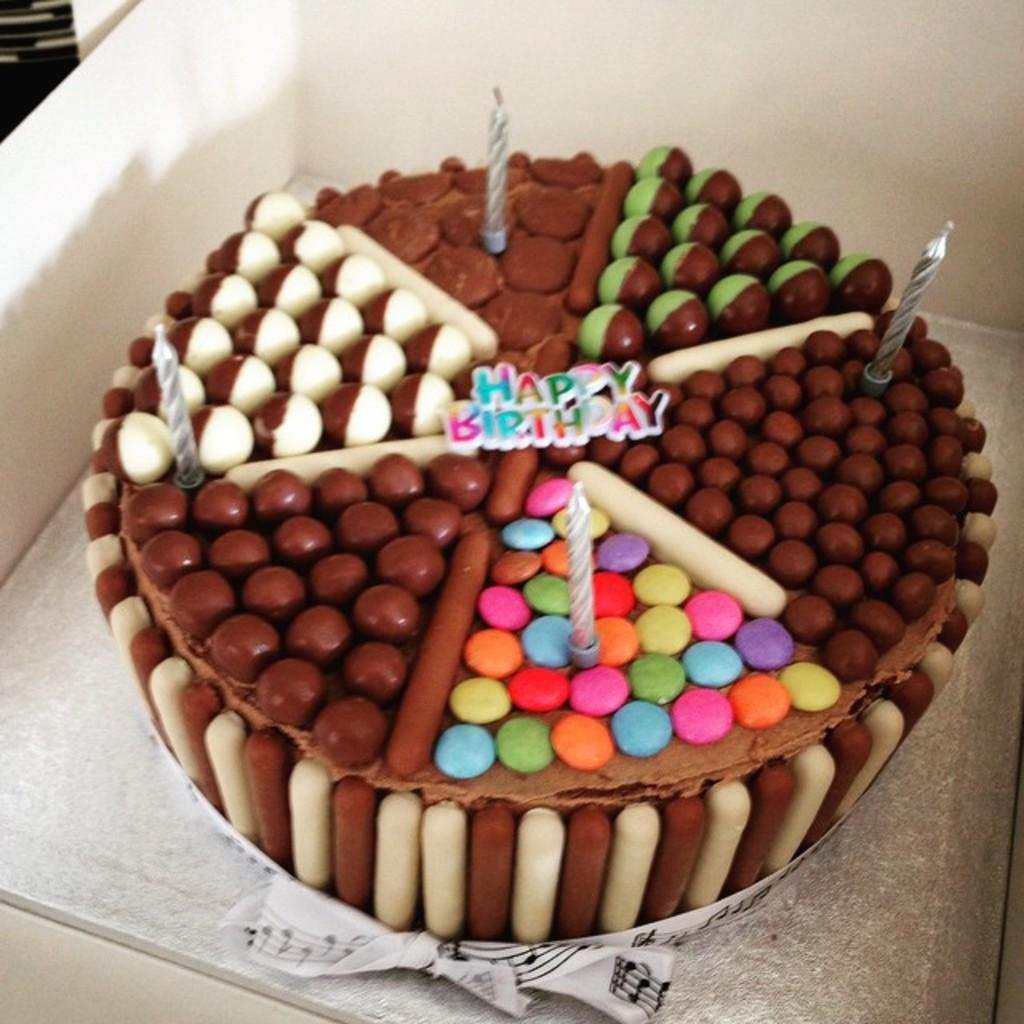What object is present in the image that contains something else? There is a box in the image that contains a cake. What type of food is inside the box? There is a cake inside the box. What is on top of the cake? The cake has candles on it. What type of boot is visible in the image? There is no boot present in the image. Is the cake on a slope in the image? The image does not show any slope; it only shows a box with a cake inside. 